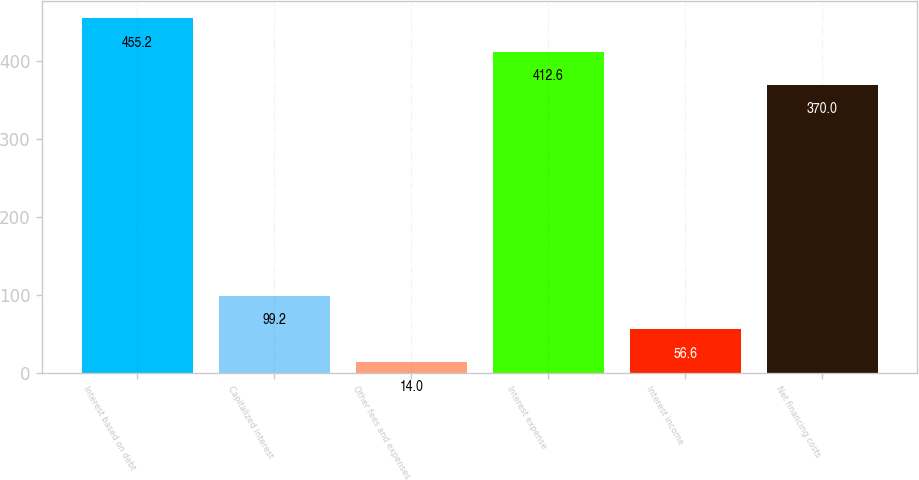Convert chart to OTSL. <chart><loc_0><loc_0><loc_500><loc_500><bar_chart><fcel>Interest based on debt<fcel>Capitalized interest<fcel>Other fees and expenses<fcel>Interest expense<fcel>Interest income<fcel>Net financing costs<nl><fcel>455.2<fcel>99.2<fcel>14<fcel>412.6<fcel>56.6<fcel>370<nl></chart> 